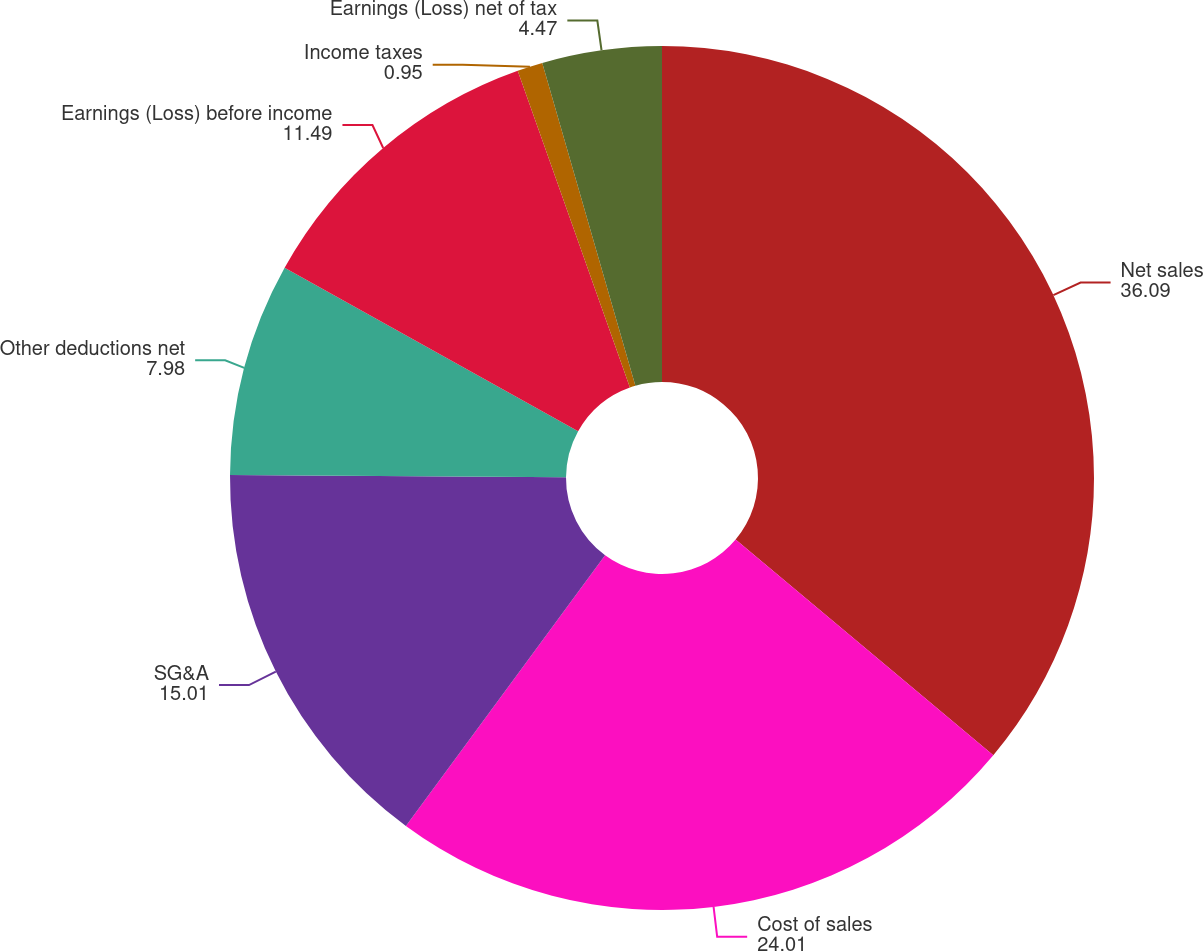<chart> <loc_0><loc_0><loc_500><loc_500><pie_chart><fcel>Net sales<fcel>Cost of sales<fcel>SG&A<fcel>Other deductions net<fcel>Earnings (Loss) before income<fcel>Income taxes<fcel>Earnings (Loss) net of tax<nl><fcel>36.09%<fcel>24.01%<fcel>15.01%<fcel>7.98%<fcel>11.49%<fcel>0.95%<fcel>4.47%<nl></chart> 